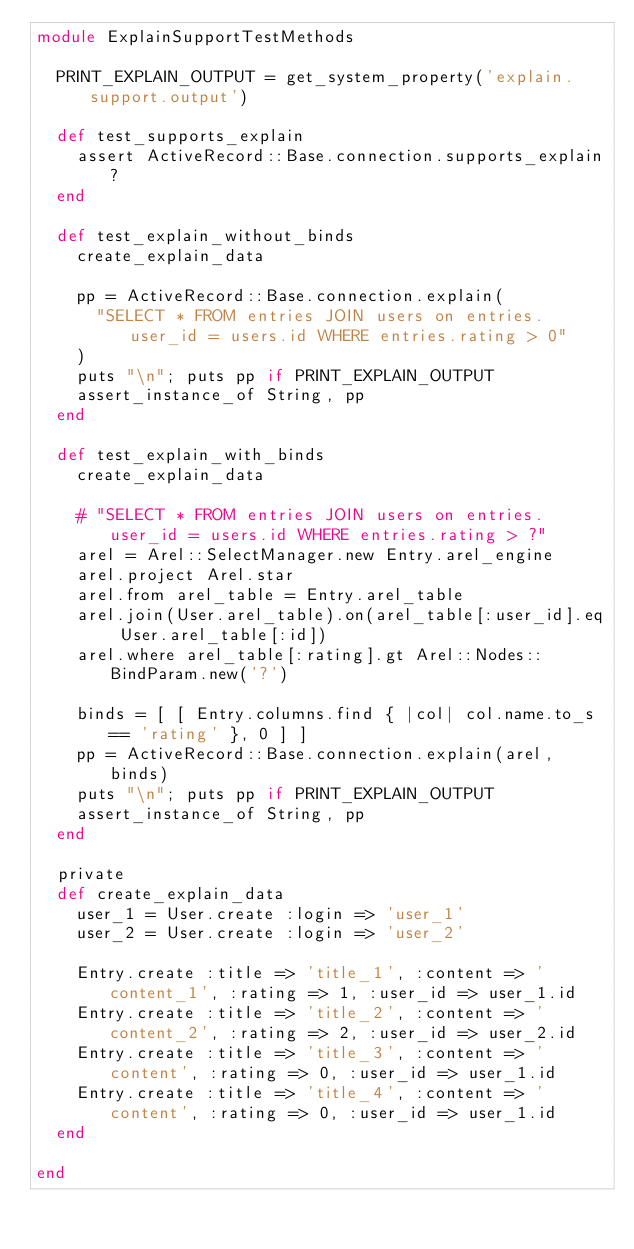Convert code to text. <code><loc_0><loc_0><loc_500><loc_500><_Ruby_>module ExplainSupportTestMethods

  PRINT_EXPLAIN_OUTPUT = get_system_property('explain.support.output')

  def test_supports_explain
    assert ActiveRecord::Base.connection.supports_explain?
  end

  def test_explain_without_binds
    create_explain_data

    pp = ActiveRecord::Base.connection.explain(
      "SELECT * FROM entries JOIN users on entries.user_id = users.id WHERE entries.rating > 0"
    )
    puts "\n"; puts pp if PRINT_EXPLAIN_OUTPUT
    assert_instance_of String, pp
  end

  def test_explain_with_binds
    create_explain_data

    # "SELECT * FROM entries JOIN users on entries.user_id = users.id WHERE entries.rating > ?"
    arel = Arel::SelectManager.new Entry.arel_engine
    arel.project Arel.star
    arel.from arel_table = Entry.arel_table
    arel.join(User.arel_table).on(arel_table[:user_id].eq User.arel_table[:id])
    arel.where arel_table[:rating].gt Arel::Nodes::BindParam.new('?')

    binds = [ [ Entry.columns.find { |col| col.name.to_s == 'rating' }, 0 ] ]
    pp = ActiveRecord::Base.connection.explain(arel, binds)
    puts "\n"; puts pp if PRINT_EXPLAIN_OUTPUT
    assert_instance_of String, pp
  end

  private
  def create_explain_data
    user_1 = User.create :login => 'user_1'
    user_2 = User.create :login => 'user_2'

    Entry.create :title => 'title_1', :content => 'content_1', :rating => 1, :user_id => user_1.id
    Entry.create :title => 'title_2', :content => 'content_2', :rating => 2, :user_id => user_2.id
    Entry.create :title => 'title_3', :content => 'content', :rating => 0, :user_id => user_1.id
    Entry.create :title => 'title_4', :content => 'content', :rating => 0, :user_id => user_1.id
  end

end</code> 